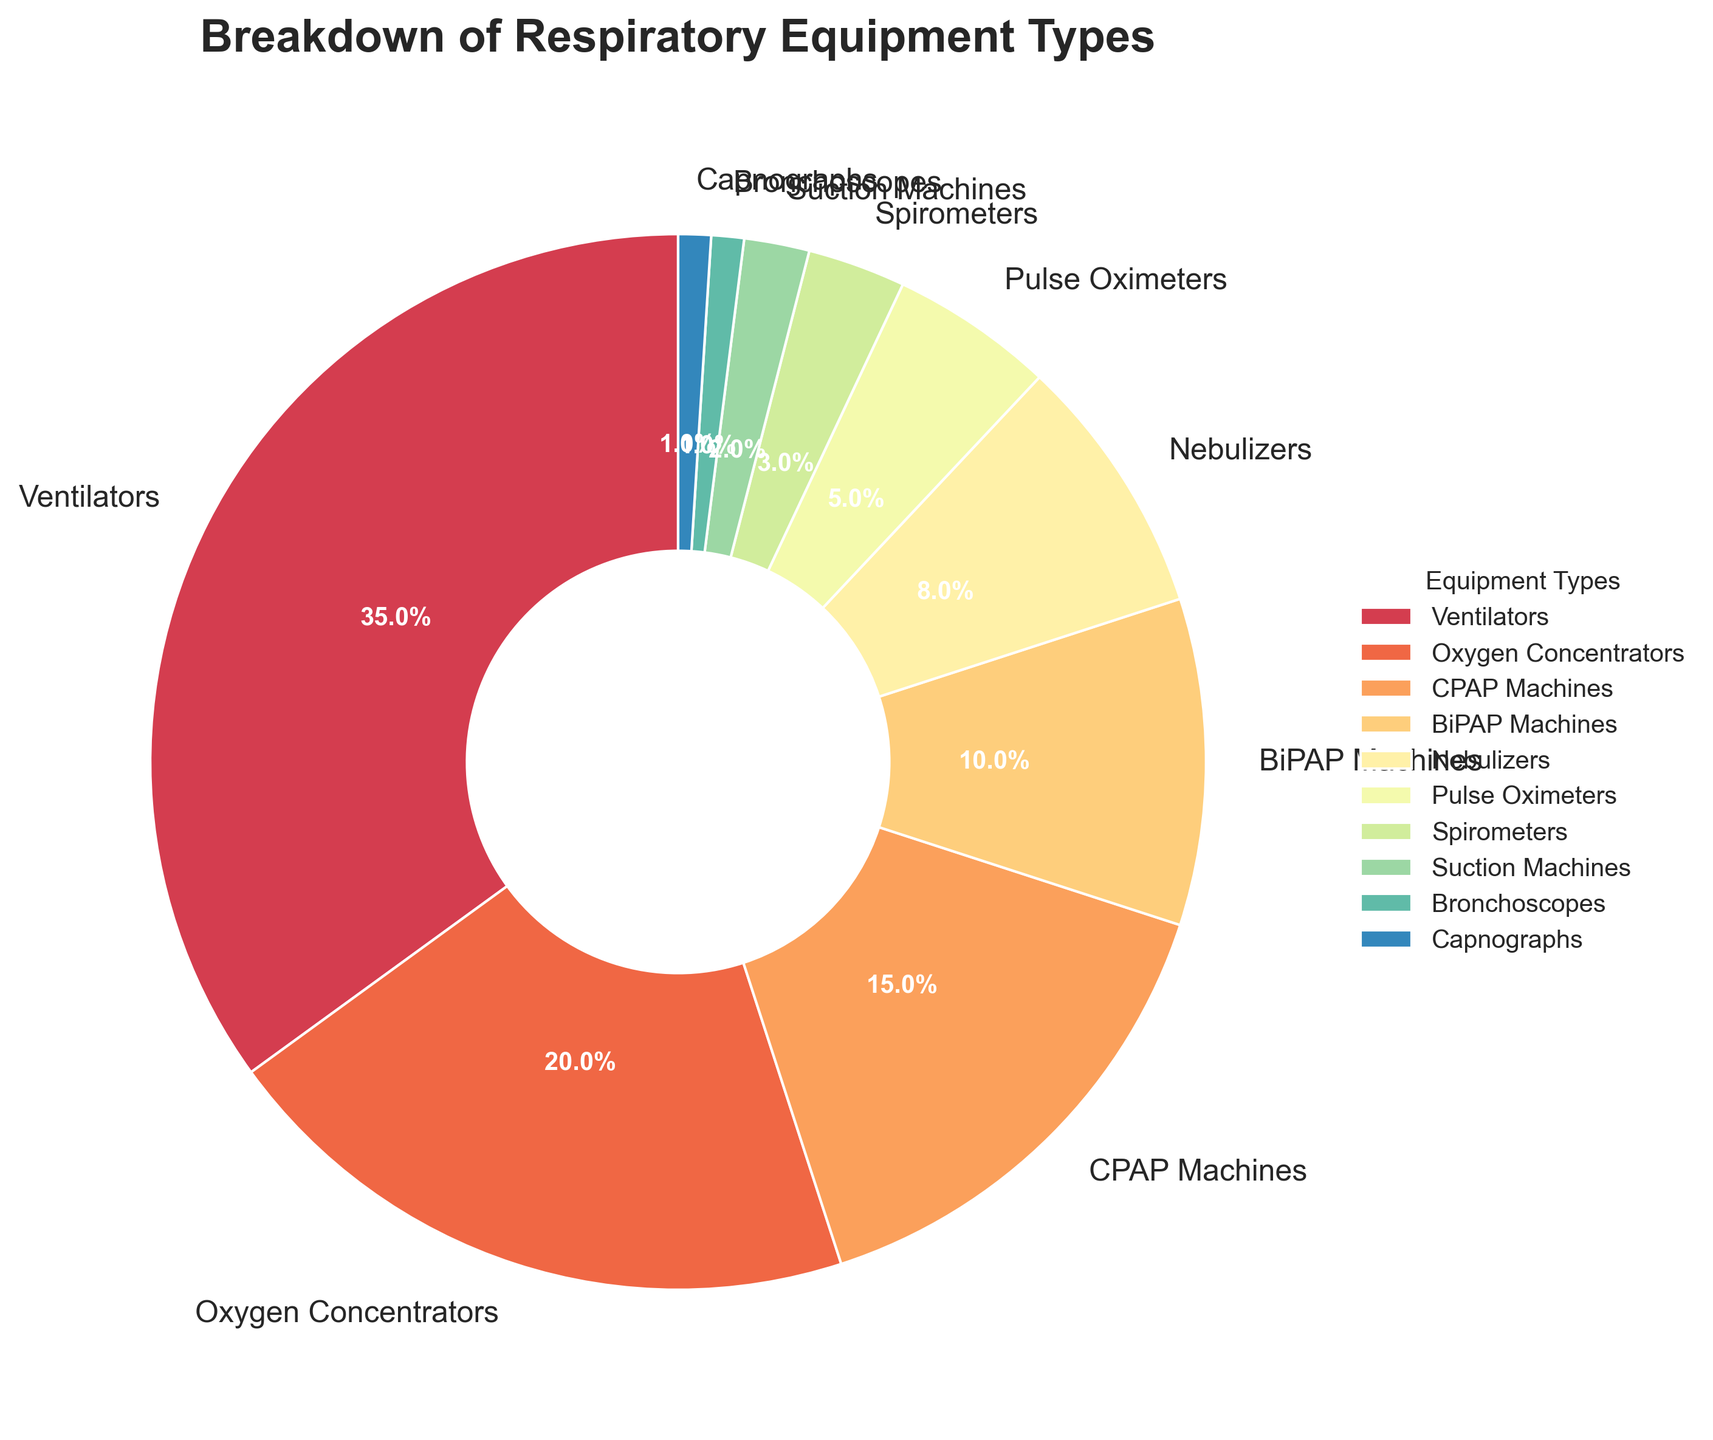How much more prevalent are ventilators compared to BiPAP machines? To find the prevalence difference between ventilators and BiPAP machines, we subtract the percentage of BiPAP machines from the percentage of ventilators: 35% (Ventilators) - 10% (BiPAP Machines) = 25%.
Answer: 25% Which two types of equipment have the lowest usage and what are their combined percentages? The two equipment types with the lowest usage are bronchoscopes and capnographs, each with 1%. Their combined percentage is the sum of their individual percentages: 1% (Bronchoscopes) + 1% (Capnographs) = 2%.
Answer: Bronchoscopes and Capnographs; 2% What percentage of the total equipment usage is made up of CPAP and BiPAP machines combined? To find the combined percentage for CPAP and BiPAP machines, we add their individual percentages: 15% (CPAP Machines) + 10% (BiPAP Machines) = 25%.
Answer: 25% How does the usage of oxygen concentrators compare to nebulizers? To compare the usage between oxygen concentrators and nebulizers, we look at their percentages: 20% (Oxygen Concentrators) is greater than 8% (Nebulizers).
Answer: Oxygen Concentrators have a higher usage than Nebulizers What is the total percentage of equipment types that each have a usage percentage below 5%? The equipment types with usage below 5% are spirometers (3%), suction machines (2%), bronchoscopes (1%), and capnographs (1%). The total percentage is their sum: 3% + 2% + 1% + 1% = 7%.
Answer: 7% Are there more oxygen concentrators in use than the combined total of spirometers and pulse oximeters? First, find the combined percentage of spirometers and pulse oximeters: 3% (Spirometers) + 5% (Pulse Oximeters) = 8%. Then, compare this with the percentage for oxygen concentrators, which is 20%. Since 20% > 8%, there are more oxygen concentrators in use.
Answer: Yes Which equipment type, among those listed, has the highest usage and what is its percentage? By examining the pie chart, we see that ventilators have the highest usage percentage at 35%.
Answer: Ventilators; 35% How many equipment types have a usage percentage of 10% or more? We need to count the equipment types with percentages 10% or more: ventilators (35%), oxygen concentrators (20%), CPAP machines (15%), BiPAP machines (10%). This gives us four types.
Answer: 4 types If the hospital decided to double the use of pulse oximeters, what would their new percentage be and would it be higher than CPAP machines? First, double the current percentage of pulse oximeters: 5% * 2 = 10%. Since CPAP machines are at 15%, even after doubling, pulse oximeters at 10% would still be less than CPAP machines at 15%.
Answer: 10%; No 